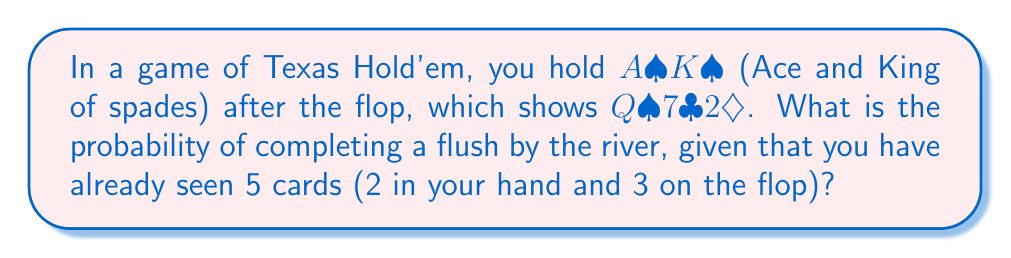Teach me how to tackle this problem. Let's approach this step-by-step:

1) First, we need to count how many spades we've seen and how many are left in the deck:
   - We have 2 spades in our hand (A♠K♠)
   - There is 1 spade on the flop (Q♠)
   - So we've seen 3 spades in total

2) There are 13 spades in a full deck. We've seen 3, so there are 10 spades left.

3) We need 2 more spades to complete our flush. We have two chances to get these: the turn and the river.

4) To calculate this probability, we'll use the concept of "outs". Our "outs" are the remaining spades.

5) The probability of hitting our flush on the turn OR the river is:

   $$P(\text{flush}) = 1 - P(\text{no flush on turn}) \times P(\text{no flush on river})$$

6) On the turn:
   - There are 47 unseen cards (52 - 5 we've seen)
   - 10 of these are spades
   - Probability of not hitting a spade = $\frac{37}{47}$

7) If we don't hit on the turn, on the river:
   - There will be 46 unseen cards
   - 10 of these will still be spades
   - Probability of not hitting a spade = $\frac{36}{46}$

8) Putting it all together:

   $$P(\text{flush}) = 1 - \frac{37}{47} \times \frac{36}{46} = 1 - 0.7872 \times 0.7826 = 0.3839$$

9) Converting to a percentage: 0.3839 * 100 = 38.39%
Answer: 38.39% 